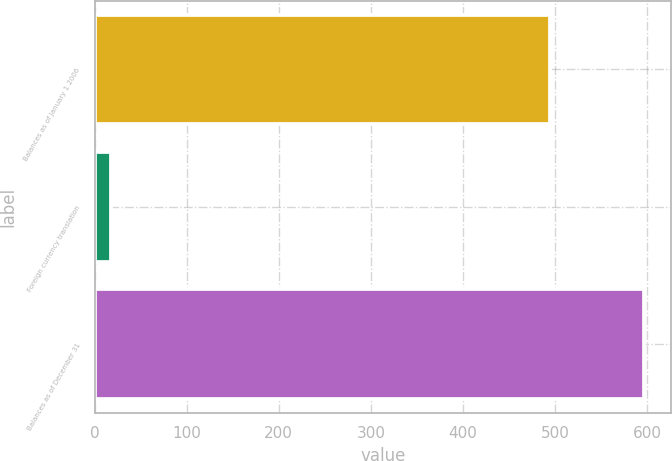Convert chart to OTSL. <chart><loc_0><loc_0><loc_500><loc_500><bar_chart><fcel>Balances as of January 1 2006<fcel>Foreign currency translation<fcel>Balances as of December 31<nl><fcel>494.3<fcel>18.2<fcel>596.14<nl></chart> 